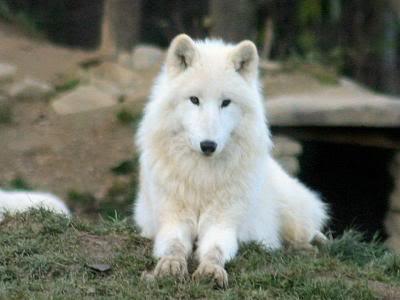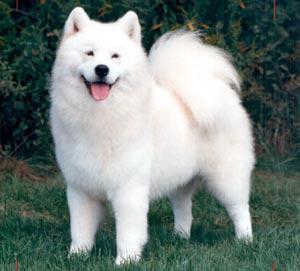The first image is the image on the left, the second image is the image on the right. Given the left and right images, does the statement "At least one dog is lying down in the image on the left." hold true? Answer yes or no. Yes. The first image is the image on the left, the second image is the image on the right. Given the left and right images, does the statement "All dogs face the same direction, and all dogs are standing on all fours." hold true? Answer yes or no. No. 